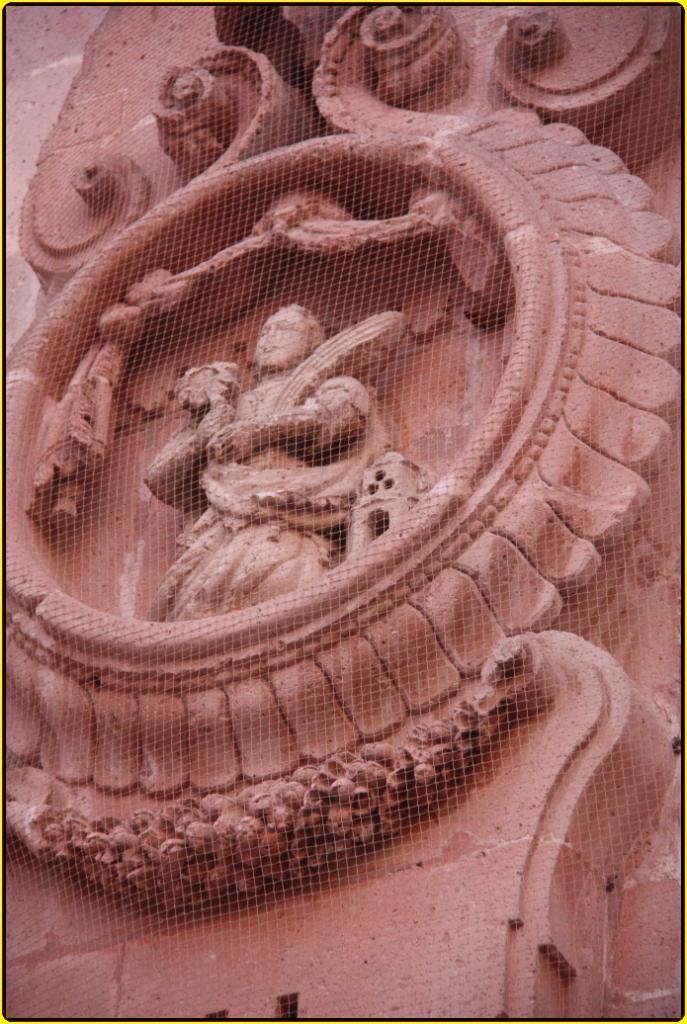Describe this image in one or two sentences. In the picture we can see a sculpture to the wall with some designs. 